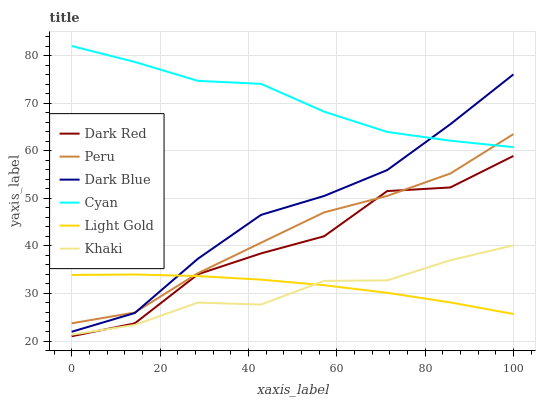Does Khaki have the minimum area under the curve?
Answer yes or no. Yes. Does Cyan have the maximum area under the curve?
Answer yes or no. Yes. Does Dark Red have the minimum area under the curve?
Answer yes or no. No. Does Dark Red have the maximum area under the curve?
Answer yes or no. No. Is Light Gold the smoothest?
Answer yes or no. Yes. Is Dark Red the roughest?
Answer yes or no. Yes. Is Dark Blue the smoothest?
Answer yes or no. No. Is Dark Blue the roughest?
Answer yes or no. No. Does Dark Blue have the lowest value?
Answer yes or no. No. Does Cyan have the highest value?
Answer yes or no. Yes. Does Dark Red have the highest value?
Answer yes or no. No. Is Khaki less than Peru?
Answer yes or no. Yes. Is Peru greater than Khaki?
Answer yes or no. Yes. Does Light Gold intersect Khaki?
Answer yes or no. Yes. Is Light Gold less than Khaki?
Answer yes or no. No. Is Light Gold greater than Khaki?
Answer yes or no. No. Does Khaki intersect Peru?
Answer yes or no. No. 